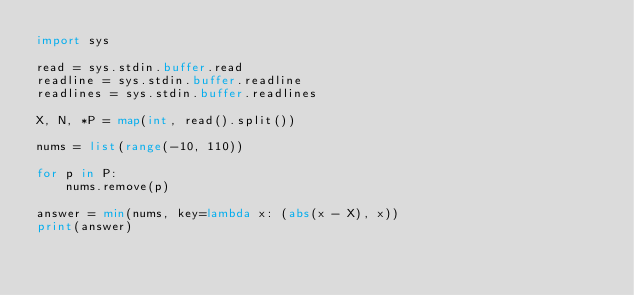Convert code to text. <code><loc_0><loc_0><loc_500><loc_500><_Python_>import sys

read = sys.stdin.buffer.read
readline = sys.stdin.buffer.readline
readlines = sys.stdin.buffer.readlines

X, N, *P = map(int, read().split())

nums = list(range(-10, 110))

for p in P:
    nums.remove(p)

answer = min(nums, key=lambda x: (abs(x - X), x))
print(answer)</code> 